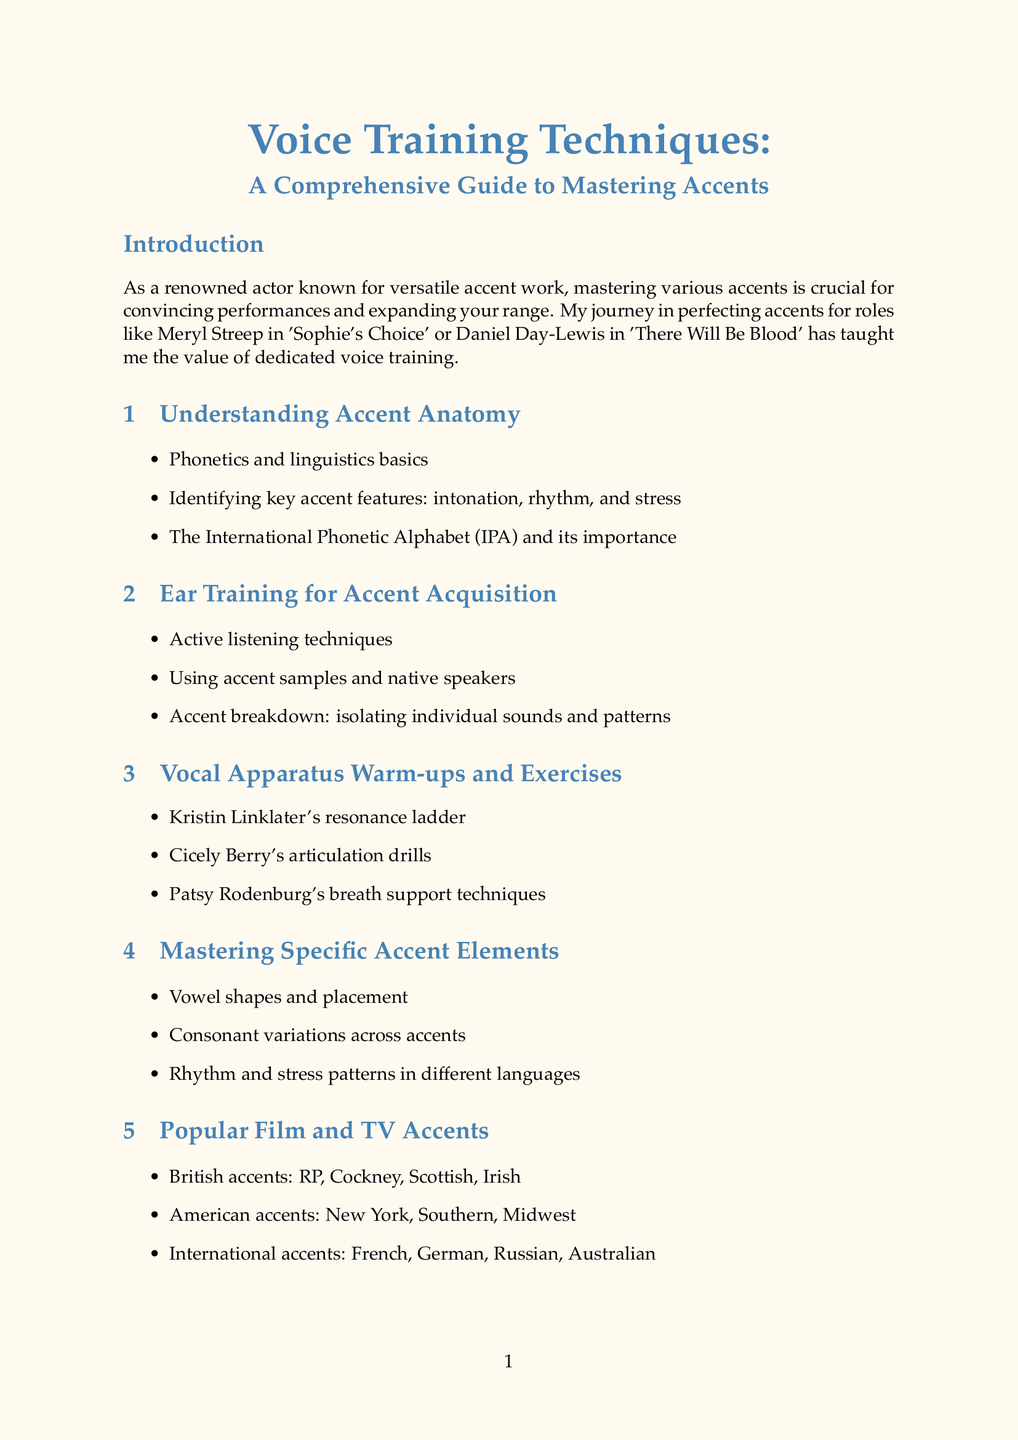What is the title of the manual? The title is explicitly mentioned at the top of the document.
Answer: Voice Training Techniques: A Comprehensive Guide to Mastering Accents Who analyzed Meryl Streep's accent in 'Sophie's Choice'? This information is found in the case studies section of the document.
Answer: Meryl Streep How many chapters are there in total? The chapters are listed in a structured format, and their count can be easily determined.
Answer: 10 What technique is associated with Cicely Berry? Specific techniques associated with notable figures are detailed in the vocal exercises section.
Answer: Articulation drills What does the "Accent Mimicry Challenge" involve? The exercises section describes what each exercise includes.
Answer: Mimicking short phrases from accent samples Which software is mentioned for speech analysis? This information is part of the technology tools section where specific software is listed.
Answer: Praat Name one of the books recommended in the resources section. The books are listed as resources, and you can easily identify one.
Answer: Speaking with Skill What is a common challenge addressed in the troubleshooting section? Common obstacles in accent work are outlined in that portion of the manual.
Answer: Accent fatigue 